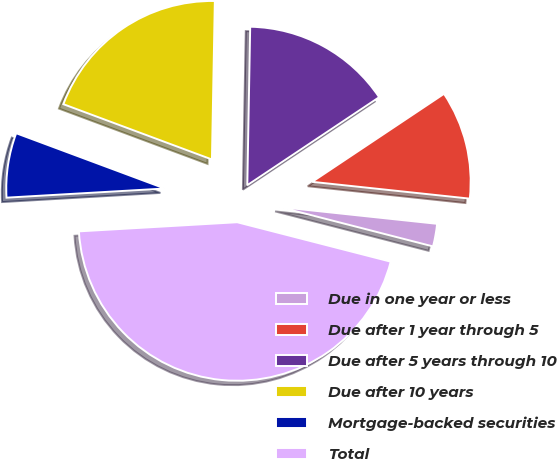Convert chart to OTSL. <chart><loc_0><loc_0><loc_500><loc_500><pie_chart><fcel>Due in one year or less<fcel>Due after 1 year through 5<fcel>Due after 5 years through 10<fcel>Due after 10 years<fcel>Mortgage-backed securities<fcel>Total<nl><fcel>2.31%<fcel>11.06%<fcel>15.34%<fcel>19.62%<fcel>6.59%<fcel>45.08%<nl></chart> 